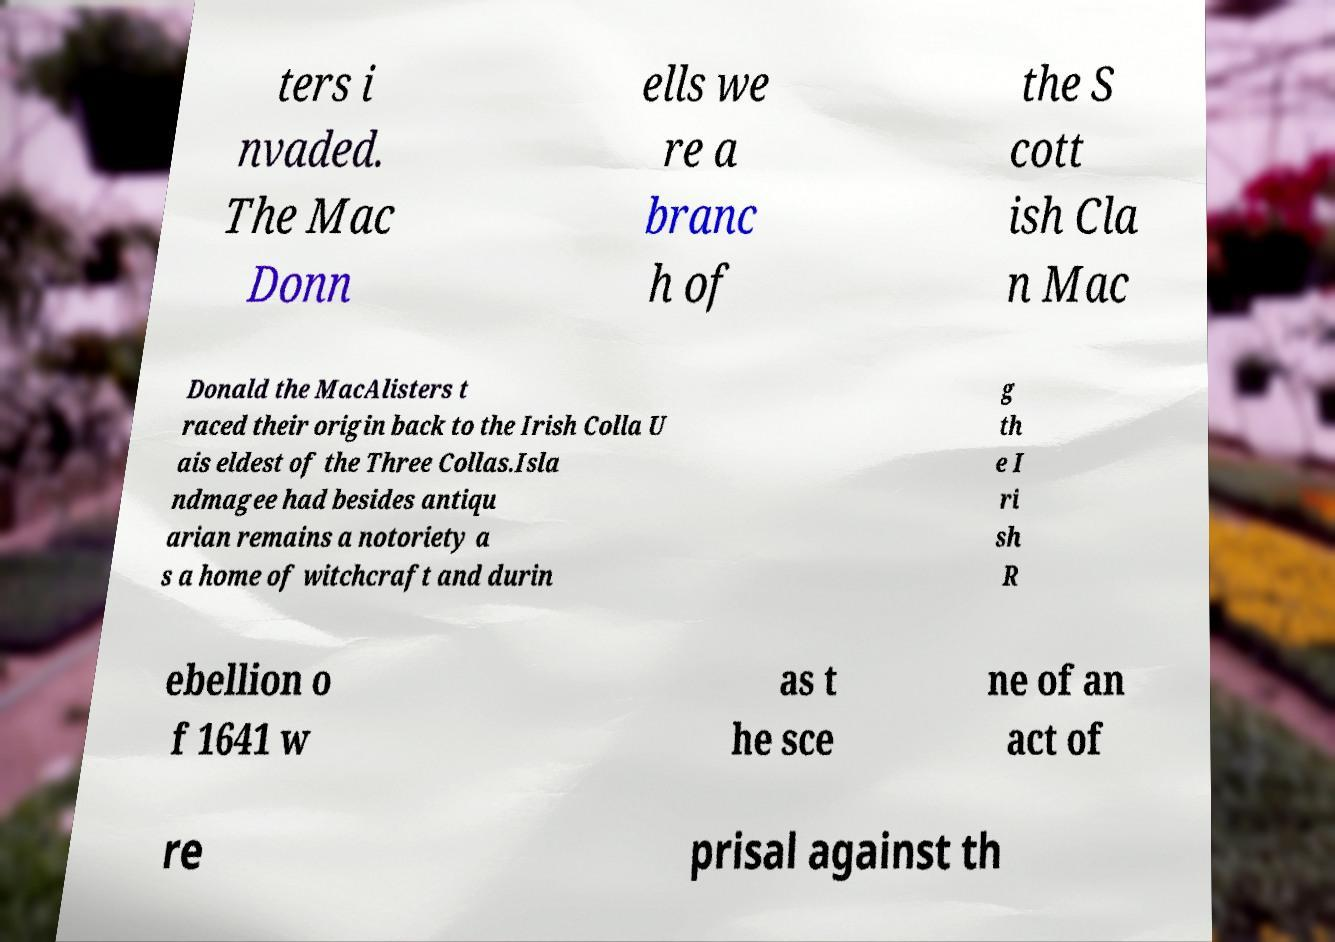There's text embedded in this image that I need extracted. Can you transcribe it verbatim? ters i nvaded. The Mac Donn ells we re a branc h of the S cott ish Cla n Mac Donald the MacAlisters t raced their origin back to the Irish Colla U ais eldest of the Three Collas.Isla ndmagee had besides antiqu arian remains a notoriety a s a home of witchcraft and durin g th e I ri sh R ebellion o f 1641 w as t he sce ne of an act of re prisal against th 